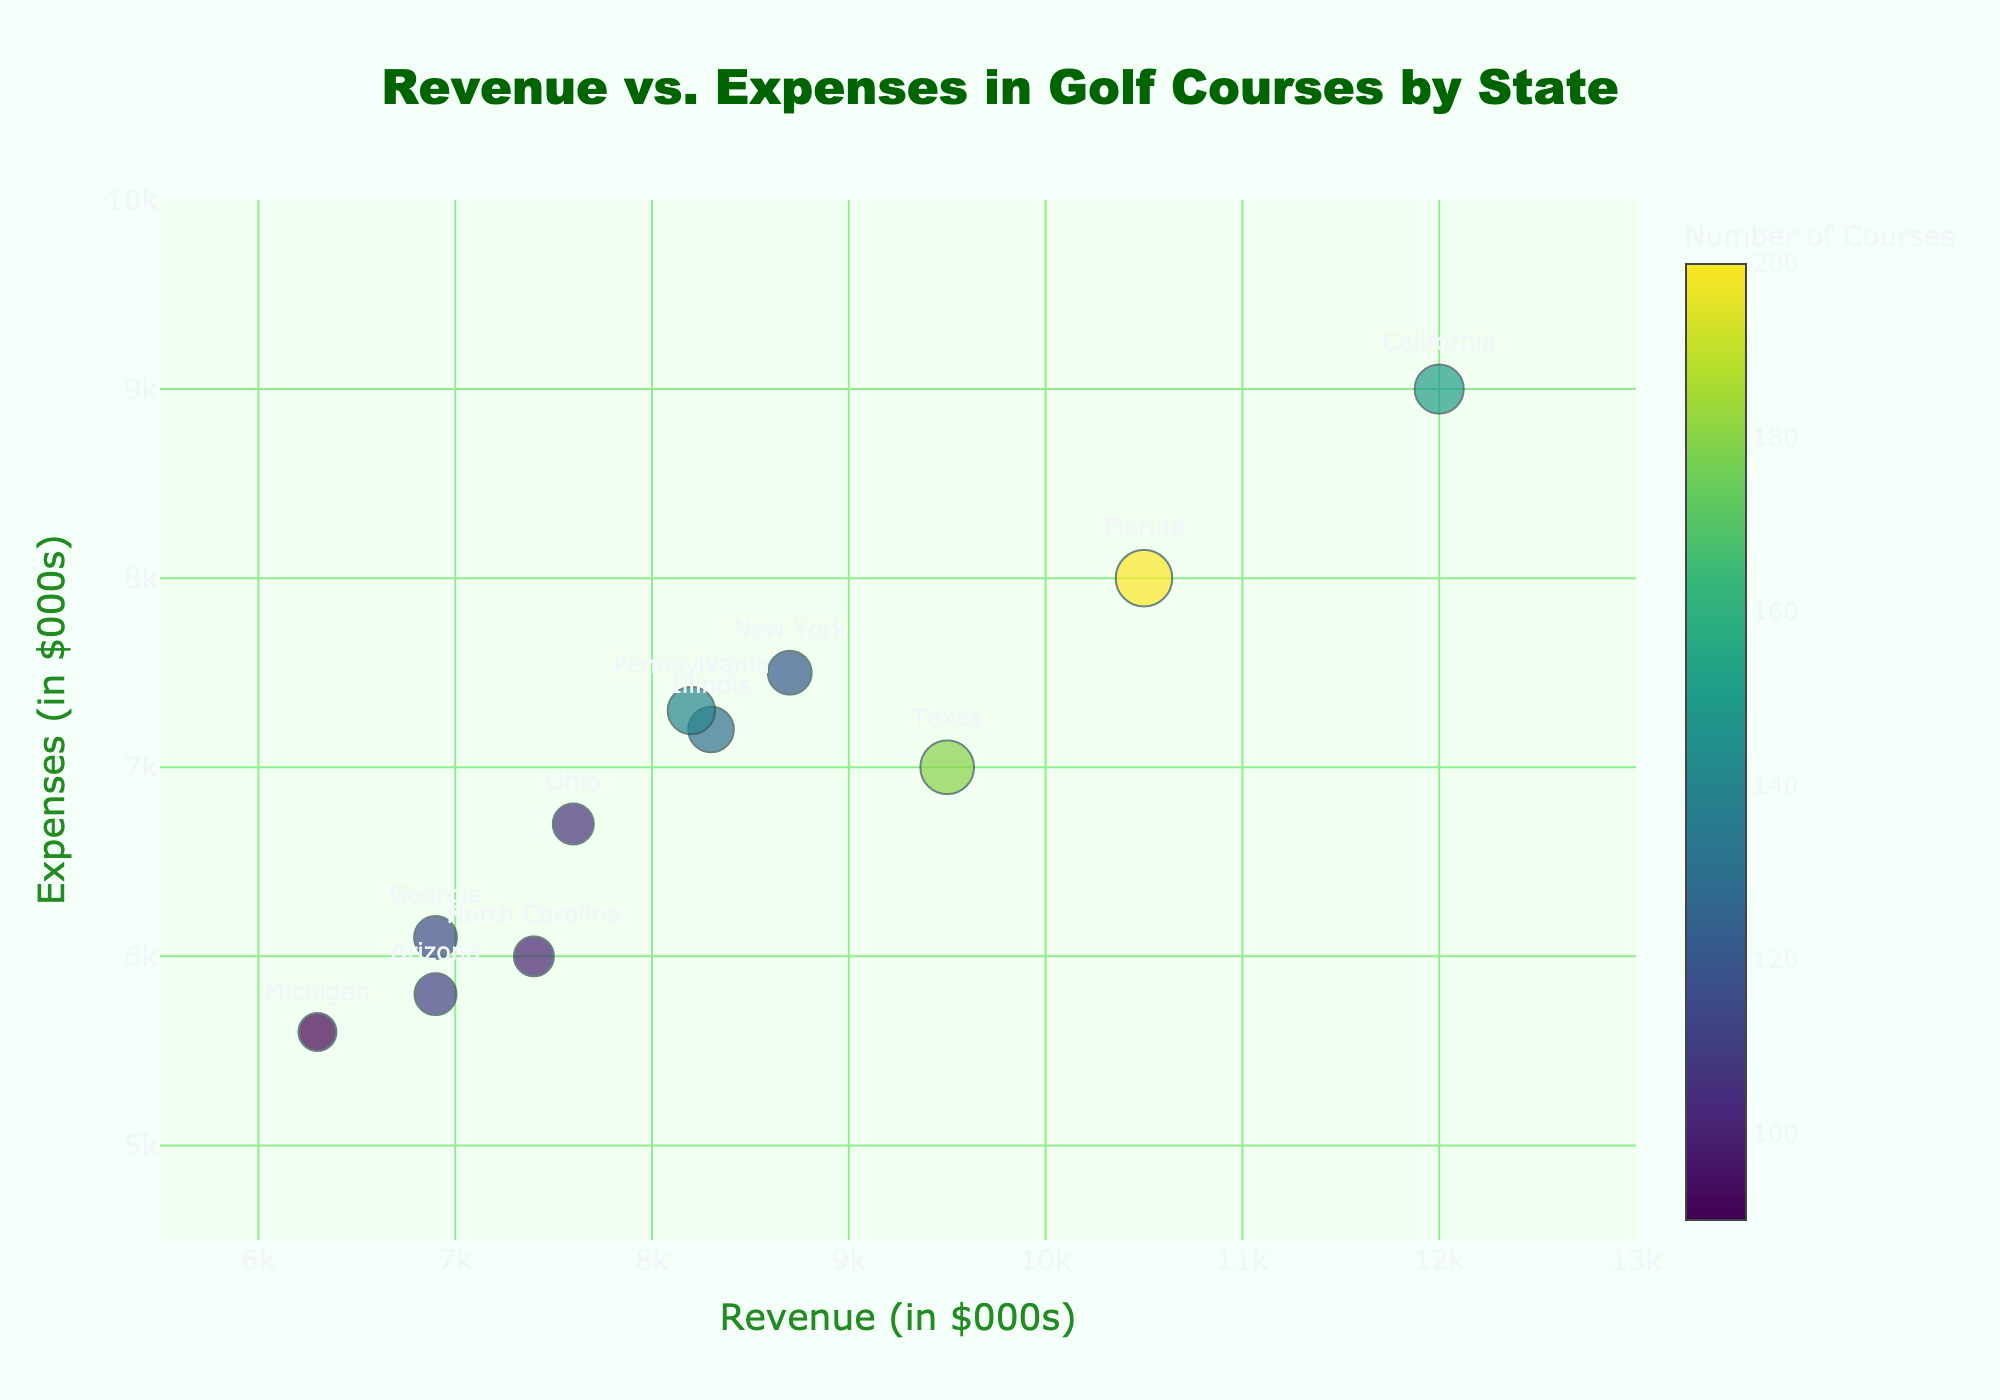What is the title of the chart? The title of the chart is placed near the top center. It reads "Revenue vs. Expenses in Golf Courses by State". This can be read directly from the figure.
Answer: Revenue vs. Expenses in Golf Courses by State Which state has the highest revenue? To find the state with the highest revenue, look for the point that is farthest to the right on the x-axis. California's bubble is positioned at 12000 on the x-axis, which is the highest revenue value.
Answer: California How many states have revenues greater than their expenses? Compare the x and y coordinates of each bubble. California, Florida, Texas, North Carolina, Michigan, and Arizona have their revenue (x-coordinate) values greater than their expenses (y-coordinate) values.
Answer: 6 Which state has the largest number of golf courses? The bubble representing the largest number of golf courses will be the largest in size. The color scale also assists in identifying it. Florida, represented by the biggest and brightest bubble, has the largest number of courses (200).
Answer: Florida What is the average number of golf courses across all states? Sum the number of courses and divide by the number of states: (150 + 200 + 180 + 120 + 100 + 90 + 110 + 130 + 115 + 105 + 140) / 11 = 14400 / 11 = 130.91.
Answer: 130.91 Which states have expenses close to $7,000, and how do their revenues compare? Identify the bubbles near the $7,000 mark on the y-axis. Texas, Ohio, and Illinois have expenses around this value. Texas has a revenue of 9500, Ohio 7600, and Illinois 8300. Texas has the highest revenue among these.
Answer: Texas, Ohio, Illinois; Texas has highest revenue Which state is closest to having equal revenue and expenses? Find the bubble closest to the line where x equals y. North Carolina is closest, with revenue at 7400 and expenses at 6000. The gap is only 1400 in the positive direction.
Answer: North Carolina What is the combined revenue of states with fewer than 100 golf courses? Add revenues of states with fewer than 100 courses: North Carolina (7400), Michigan (6300), Arizona (6900), and Georgia (6900). Combined: 7400 + 6300 + 6900 + 6900 = 27500.
Answer: 27500 Which state has the smallest bubble size and what does it represent? The smallest bubble by size represents the smallest number of courses. Michigan, with 90 courses, has the smallest bubble.
Answer: Michigan, 90 courses Is there a correlation between revenue and number of courses? Correlation can be inferred by observing the general trend of bubble sizes along the x-axis (revenue). States with higher revenue like California and Florida have larger bubbles, indicating more courses. Conversely, states with lower revenue have smaller bubbles. This suggests a positive correlation.
Answer: Yes 